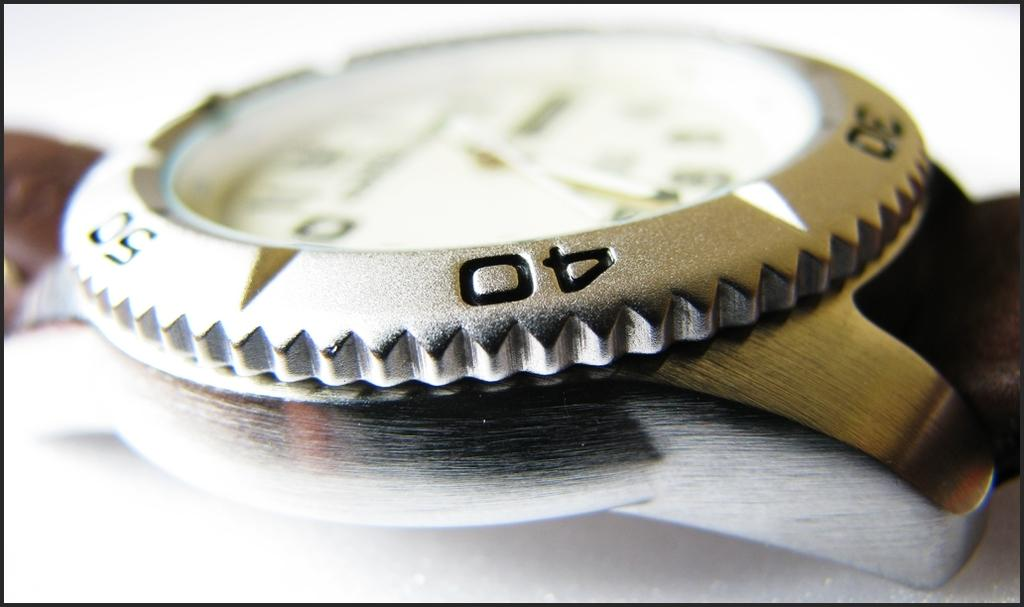<image>
Create a compact narrative representing the image presented. An analog watch surrounde by 30, 40 and 50 in the metal around it, on a brown band. 